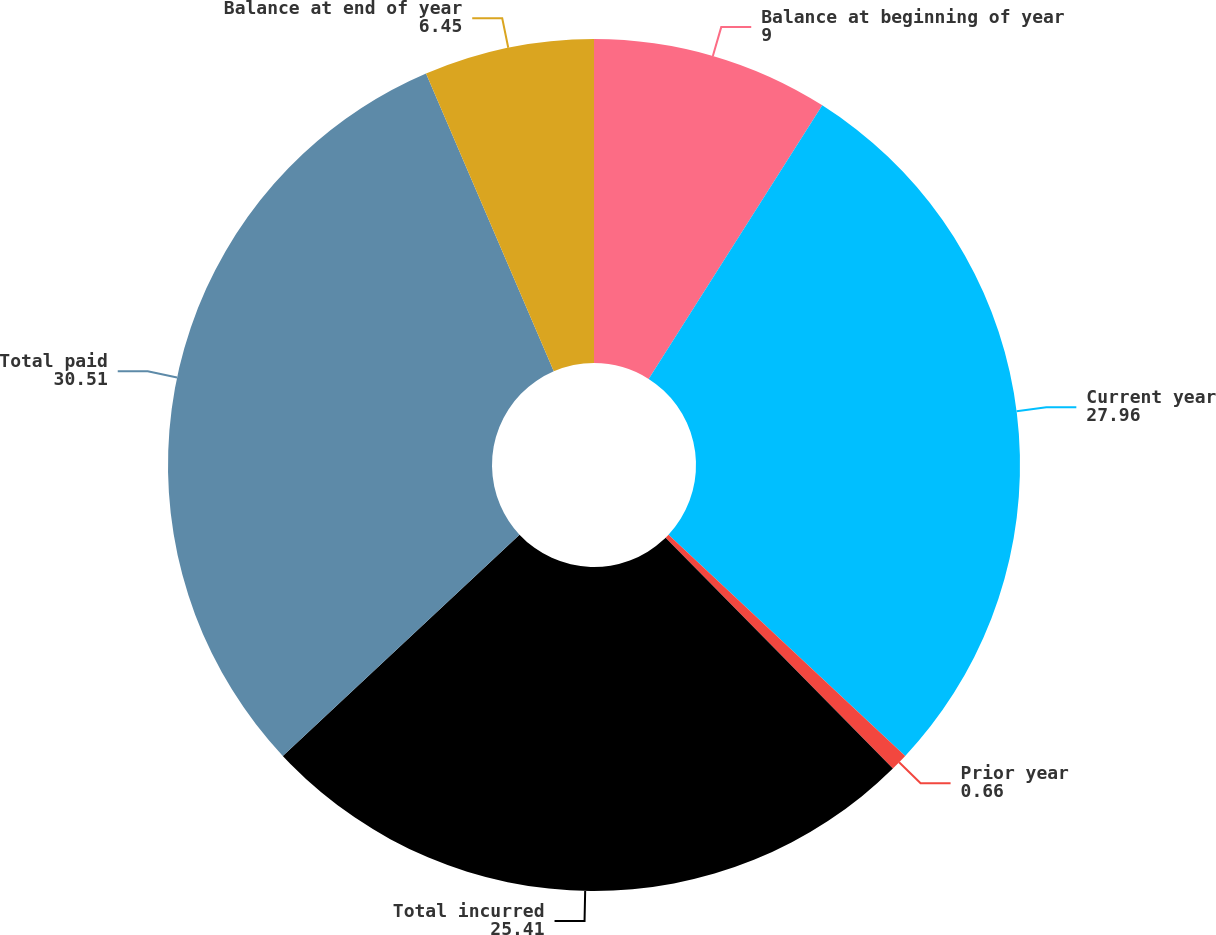Convert chart. <chart><loc_0><loc_0><loc_500><loc_500><pie_chart><fcel>Balance at beginning of year<fcel>Current year<fcel>Prior year<fcel>Total incurred<fcel>Total paid<fcel>Balance at end of year<nl><fcel>9.0%<fcel>27.96%<fcel>0.66%<fcel>25.41%<fcel>30.51%<fcel>6.45%<nl></chart> 